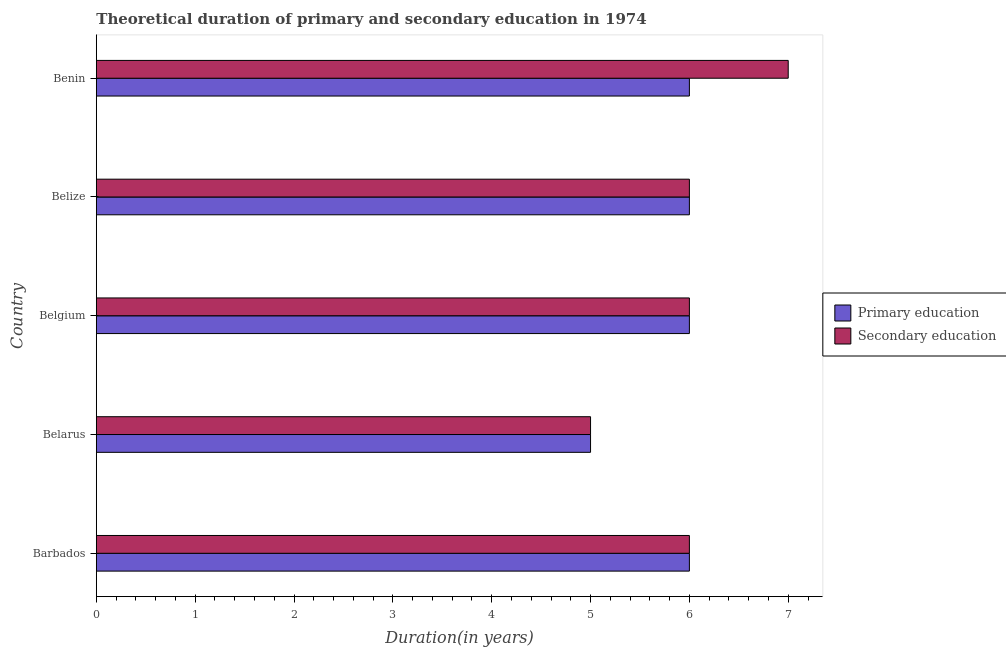How many groups of bars are there?
Keep it short and to the point. 5. Are the number of bars per tick equal to the number of legend labels?
Offer a very short reply. Yes. Are the number of bars on each tick of the Y-axis equal?
Provide a succinct answer. Yes. How many bars are there on the 2nd tick from the top?
Make the answer very short. 2. How many bars are there on the 1st tick from the bottom?
Your response must be concise. 2. What is the label of the 4th group of bars from the top?
Give a very brief answer. Belarus. In how many cases, is the number of bars for a given country not equal to the number of legend labels?
Make the answer very short. 0. Across all countries, what is the maximum duration of secondary education?
Provide a short and direct response. 7. Across all countries, what is the minimum duration of secondary education?
Keep it short and to the point. 5. In which country was the duration of secondary education maximum?
Offer a terse response. Benin. In which country was the duration of primary education minimum?
Your response must be concise. Belarus. What is the total duration of primary education in the graph?
Your answer should be compact. 29. What is the difference between the duration of primary education in Barbados and that in Belgium?
Provide a succinct answer. 0. What is the difference between the duration of secondary education in Belize and the duration of primary education in Belarus?
Keep it short and to the point. 1. What is the difference between the duration of secondary education and duration of primary education in Barbados?
Your answer should be very brief. 0. In how many countries, is the duration of primary education greater than 6.2 years?
Your answer should be very brief. 0. What is the ratio of the duration of primary education in Belarus to that in Benin?
Offer a terse response. 0.83. Is the duration of secondary education in Belgium less than that in Belize?
Your answer should be very brief. No. Is the difference between the duration of primary education in Belarus and Benin greater than the difference between the duration of secondary education in Belarus and Benin?
Provide a short and direct response. Yes. What is the difference between the highest and the lowest duration of primary education?
Your answer should be compact. 1. What does the 1st bar from the top in Belgium represents?
Your answer should be compact. Secondary education. What does the 2nd bar from the bottom in Benin represents?
Offer a terse response. Secondary education. How many countries are there in the graph?
Offer a terse response. 5. What is the difference between two consecutive major ticks on the X-axis?
Make the answer very short. 1. Where does the legend appear in the graph?
Give a very brief answer. Center right. How many legend labels are there?
Provide a succinct answer. 2. What is the title of the graph?
Offer a terse response. Theoretical duration of primary and secondary education in 1974. What is the label or title of the X-axis?
Offer a very short reply. Duration(in years). What is the label or title of the Y-axis?
Make the answer very short. Country. What is the Duration(in years) in Primary education in Barbados?
Your answer should be very brief. 6. What is the Duration(in years) of Primary education in Belarus?
Give a very brief answer. 5. What is the Duration(in years) of Secondary education in Belarus?
Ensure brevity in your answer.  5. What is the Duration(in years) of Secondary education in Belgium?
Your answer should be very brief. 6. What is the Duration(in years) in Secondary education in Belize?
Your answer should be compact. 6. What is the Duration(in years) in Primary education in Benin?
Your response must be concise. 6. What is the Duration(in years) in Secondary education in Benin?
Make the answer very short. 7. Across all countries, what is the maximum Duration(in years) in Primary education?
Make the answer very short. 6. What is the difference between the Duration(in years) of Primary education in Barbados and that in Belarus?
Your answer should be very brief. 1. What is the difference between the Duration(in years) of Primary education in Barbados and that in Belgium?
Ensure brevity in your answer.  0. What is the difference between the Duration(in years) in Secondary education in Barbados and that in Belize?
Give a very brief answer. 0. What is the difference between the Duration(in years) in Primary education in Belarus and that in Belgium?
Your answer should be very brief. -1. What is the difference between the Duration(in years) of Primary education in Belarus and that in Benin?
Provide a succinct answer. -1. What is the difference between the Duration(in years) in Secondary education in Belarus and that in Benin?
Provide a short and direct response. -2. What is the difference between the Duration(in years) of Primary education in Belgium and that in Belize?
Keep it short and to the point. 0. What is the difference between the Duration(in years) of Secondary education in Belgium and that in Belize?
Offer a very short reply. 0. What is the difference between the Duration(in years) of Primary education in Belize and that in Benin?
Ensure brevity in your answer.  0. What is the difference between the Duration(in years) of Secondary education in Belize and that in Benin?
Make the answer very short. -1. What is the difference between the Duration(in years) in Primary education in Barbados and the Duration(in years) in Secondary education in Belgium?
Ensure brevity in your answer.  0. What is the difference between the Duration(in years) in Primary education in Belarus and the Duration(in years) in Secondary education in Belize?
Provide a short and direct response. -1. What is the difference between the Duration(in years) of Primary education in Belgium and the Duration(in years) of Secondary education in Belize?
Keep it short and to the point. 0. What is the difference between the Duration(in years) of Primary education in Belgium and the Duration(in years) of Secondary education in Benin?
Give a very brief answer. -1. What is the difference between the Duration(in years) of Primary education in Belize and the Duration(in years) of Secondary education in Benin?
Make the answer very short. -1. What is the difference between the Duration(in years) of Primary education and Duration(in years) of Secondary education in Barbados?
Provide a succinct answer. 0. What is the ratio of the Duration(in years) of Secondary education in Barbados to that in Belarus?
Your answer should be very brief. 1.2. What is the ratio of the Duration(in years) of Primary education in Barbados to that in Benin?
Your answer should be compact. 1. What is the ratio of the Duration(in years) in Primary education in Belarus to that in Belgium?
Provide a succinct answer. 0.83. What is the ratio of the Duration(in years) of Primary education in Belarus to that in Belize?
Your answer should be very brief. 0.83. What is the ratio of the Duration(in years) of Secondary education in Belarus to that in Belize?
Provide a short and direct response. 0.83. What is the ratio of the Duration(in years) in Primary education in Belarus to that in Benin?
Provide a succinct answer. 0.83. What is the ratio of the Duration(in years) in Primary education in Belgium to that in Belize?
Make the answer very short. 1. What is the ratio of the Duration(in years) of Primary education in Belgium to that in Benin?
Offer a very short reply. 1. What is the ratio of the Duration(in years) in Secondary education in Belgium to that in Benin?
Give a very brief answer. 0.86. What is the ratio of the Duration(in years) of Primary education in Belize to that in Benin?
Your response must be concise. 1. What is the ratio of the Duration(in years) of Secondary education in Belize to that in Benin?
Offer a terse response. 0.86. What is the difference between the highest and the second highest Duration(in years) in Primary education?
Ensure brevity in your answer.  0. What is the difference between the highest and the lowest Duration(in years) in Secondary education?
Your answer should be compact. 2. 